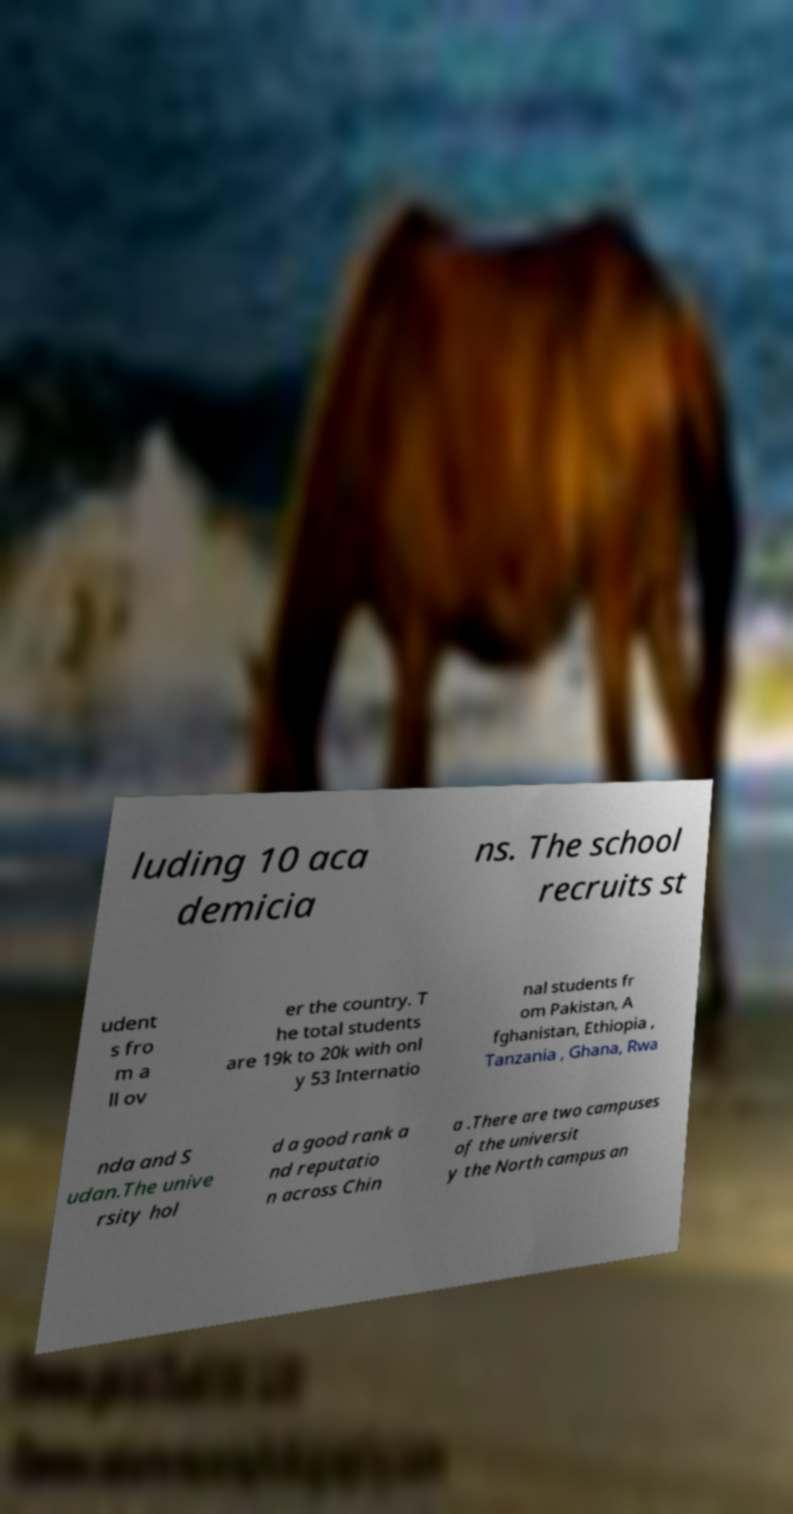Could you assist in decoding the text presented in this image and type it out clearly? luding 10 aca demicia ns. The school recruits st udent s fro m a ll ov er the country. T he total students are 19k to 20k with onl y 53 Internatio nal students fr om Pakistan, A fghanistan, Ethiopia , Tanzania , Ghana, Rwa nda and S udan.The unive rsity hol d a good rank a nd reputatio n across Chin a .There are two campuses of the universit y the North campus an 